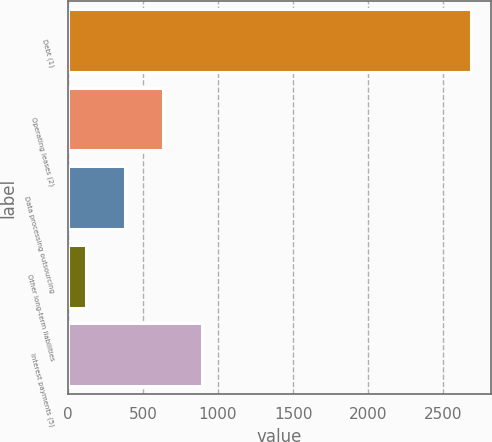Convert chart. <chart><loc_0><loc_0><loc_500><loc_500><bar_chart><fcel>Debt (1)<fcel>Operating leases (2)<fcel>Data processing outsourcing<fcel>Other long-term liabilities<fcel>Interest payments (5)<nl><fcel>2685.4<fcel>635.16<fcel>378.88<fcel>122.6<fcel>891.44<nl></chart> 